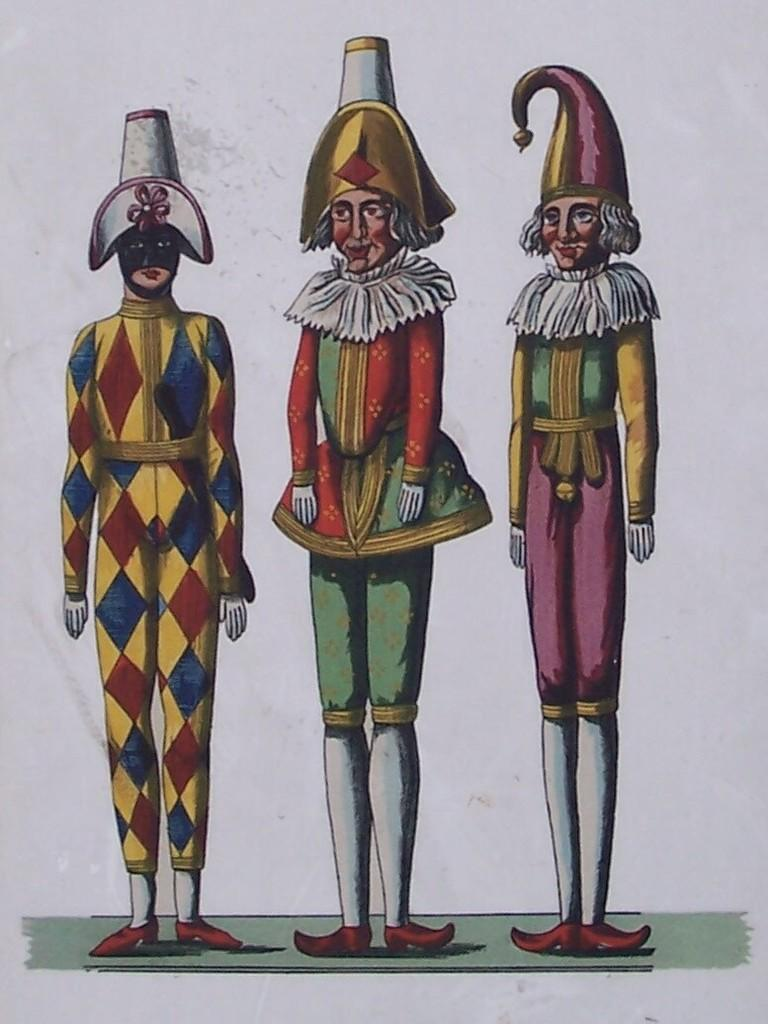How many toys are present in the image? There are three toys in the image. Can you describe the appearance of the toys? The toys are in different color dresses. What is the color of the background in the image? The background of the image is white. What type of pies can be seen in the image? There are no pies present in the image; it features three toys in different color dresses. How many horses are visible in the image? There are no horses visible in the image. 